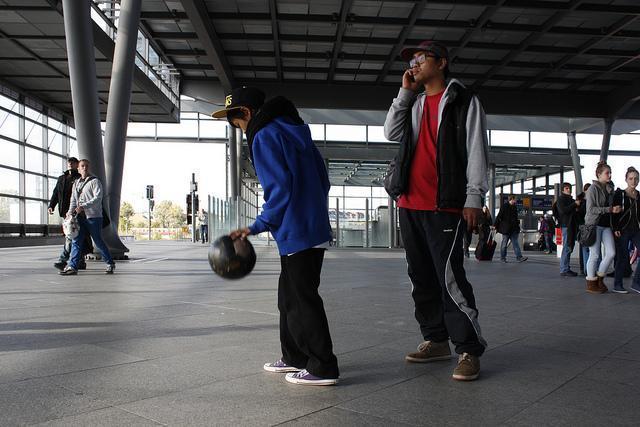What is the boy doing with the black ball?
Choose the correct response, then elucidate: 'Answer: answer
Rationale: rationale.'
Options: Dribbling, passing, throwing, polishing. Answer: dribbling.
Rationale: The way his hand is placed over top of it, shows he is bouncing the ball, or "dribbling" as it is called in basketball. 